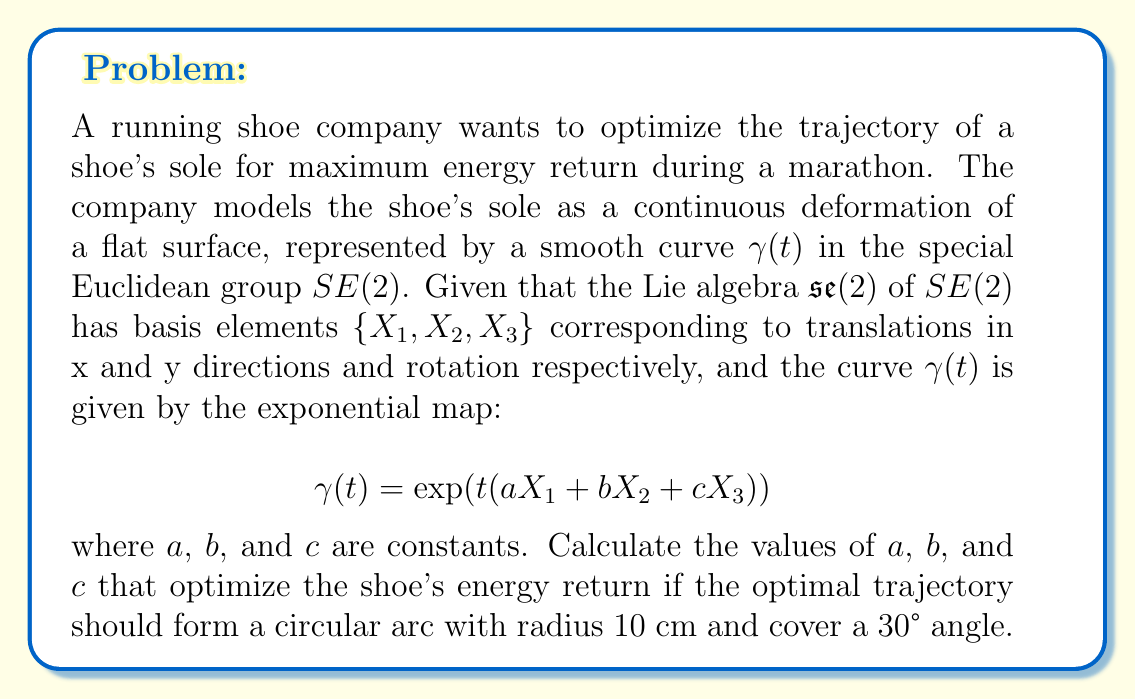Solve this math problem. To solve this problem, we need to use the properties of the special Euclidean group $SE(2)$ and its Lie algebra $\mathfrak{se}(2)$. Let's break it down step by step:

1) The exponential map for $SE(2)$ is given by:

   $$\exp(t(aX_1 + bX_2 + cX_3)) = \begin{pmatrix}
   \cos(ct) & -\sin(ct) & \frac{a\sin(ct) + b(1-\cos(ct))}{c} \\
   \sin(ct) & \cos(ct) & \frac{b\sin(ct) - a(1-\cos(ct))}{c} \\
   0 & 0 & 1
   \end{pmatrix}$$

2) For a circular arc:
   - The radius is 10 cm, so the center of rotation should be 10 cm away from the origin.
   - The angle covered is 30°, which is $\frac{\pi}{6}$ radians.

3) At $t = 1$, the curve should end at the point $(10 - 10\cos(\frac{\pi}{6}), 10\sin(\frac{\pi}{6}))$. This gives us two equations:

   $$\frac{a\sin(c) + b(1-\cos(c))}{c} = 10 - 10\cos(\frac{\pi}{6})$$
   $$\frac{b\sin(c) - a(1-\cos(c))}{c} = 10\sin(\frac{\pi}{6})$$

4) We also know that $c = \frac{\pi}{6}$ because this is the total angle of rotation.

5) Substituting $c = \frac{\pi}{6}$ into the equations from step 3:

   $$\frac{a\sin(\frac{\pi}{6}) + b(1-\cos(\frac{\pi}{6}))}{\frac{\pi}{6}} = 10 - 10\cos(\frac{\pi}{6})$$
   $$\frac{b\sin(\frac{\pi}{6}) - a(1-\cos(\frac{\pi}{6}))}{\frac{\pi}{6}} = 10\sin(\frac{\pi}{6})$$

6) Simplifying:

   $$a\cdot 0.5 + b\cdot 0.134 = 1.34$$
   $$b\cdot 0.5 - a\cdot 0.134 = 5$$

7) Solving this system of equations:

   $$a = 10\pi/3 \approx 10.47$$
   $$b = 10\pi/\sqrt{3} \approx 18.14$$

Therefore, the optimal values are $a \approx 10.47$, $b \approx 18.14$, and $c = \pi/6 \approx 0.52$.
Answer: $a = 10\pi/3 \approx 10.47$, $b = 10\pi/\sqrt{3} \approx 18.14$, $c = \pi/6 \approx 0.52$ 